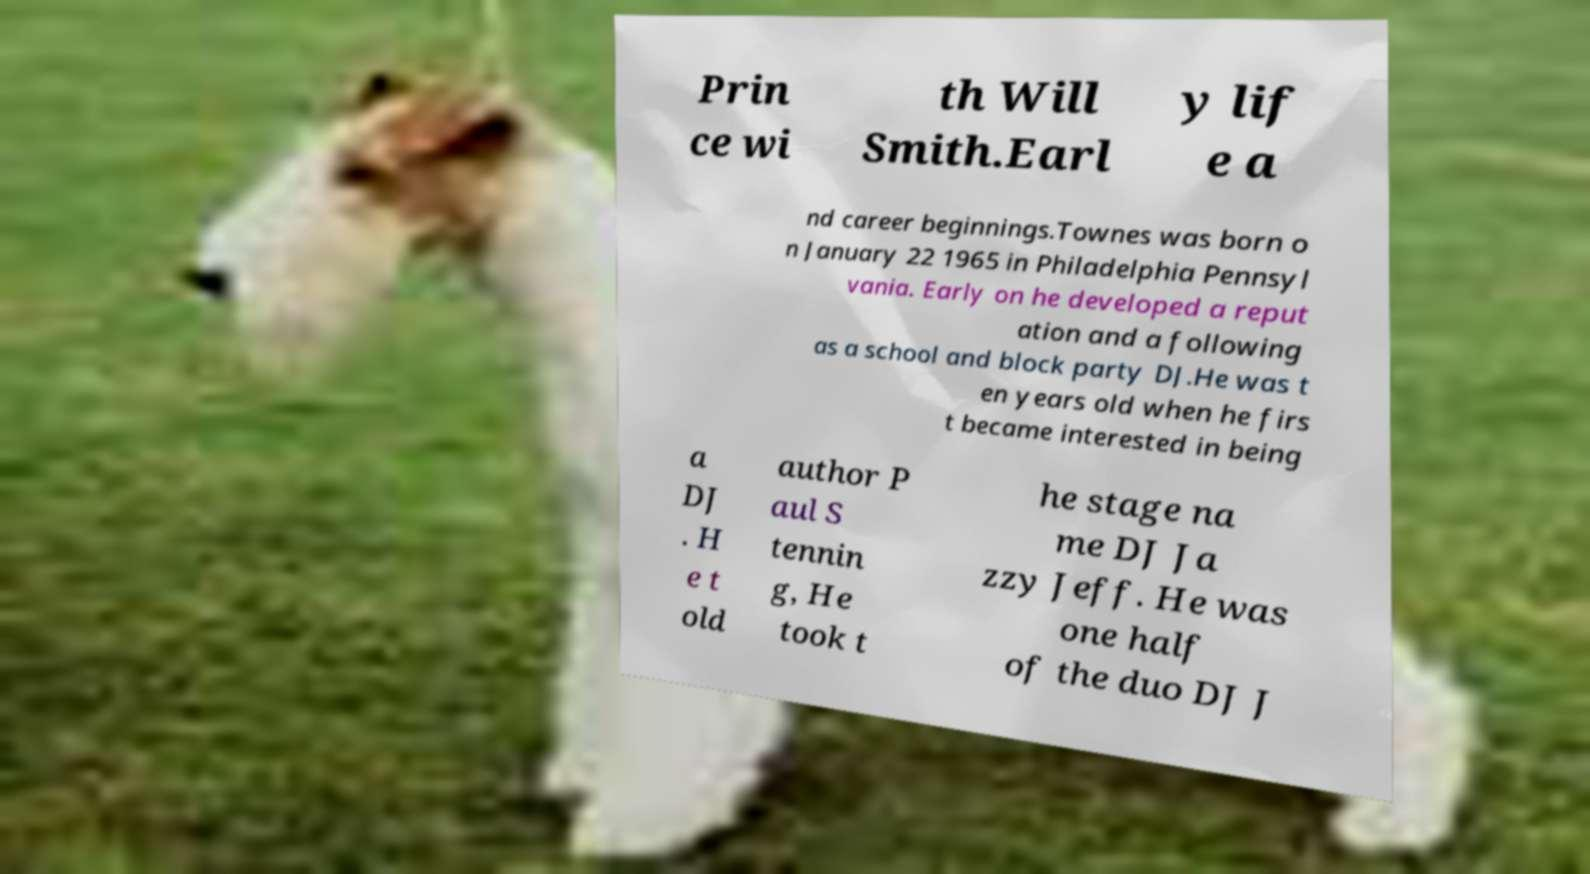Can you read and provide the text displayed in the image?This photo seems to have some interesting text. Can you extract and type it out for me? Prin ce wi th Will Smith.Earl y lif e a nd career beginnings.Townes was born o n January 22 1965 in Philadelphia Pennsyl vania. Early on he developed a reput ation and a following as a school and block party DJ.He was t en years old when he firs t became interested in being a DJ . H e t old author P aul S tennin g, He took t he stage na me DJ Ja zzy Jeff. He was one half of the duo DJ J 